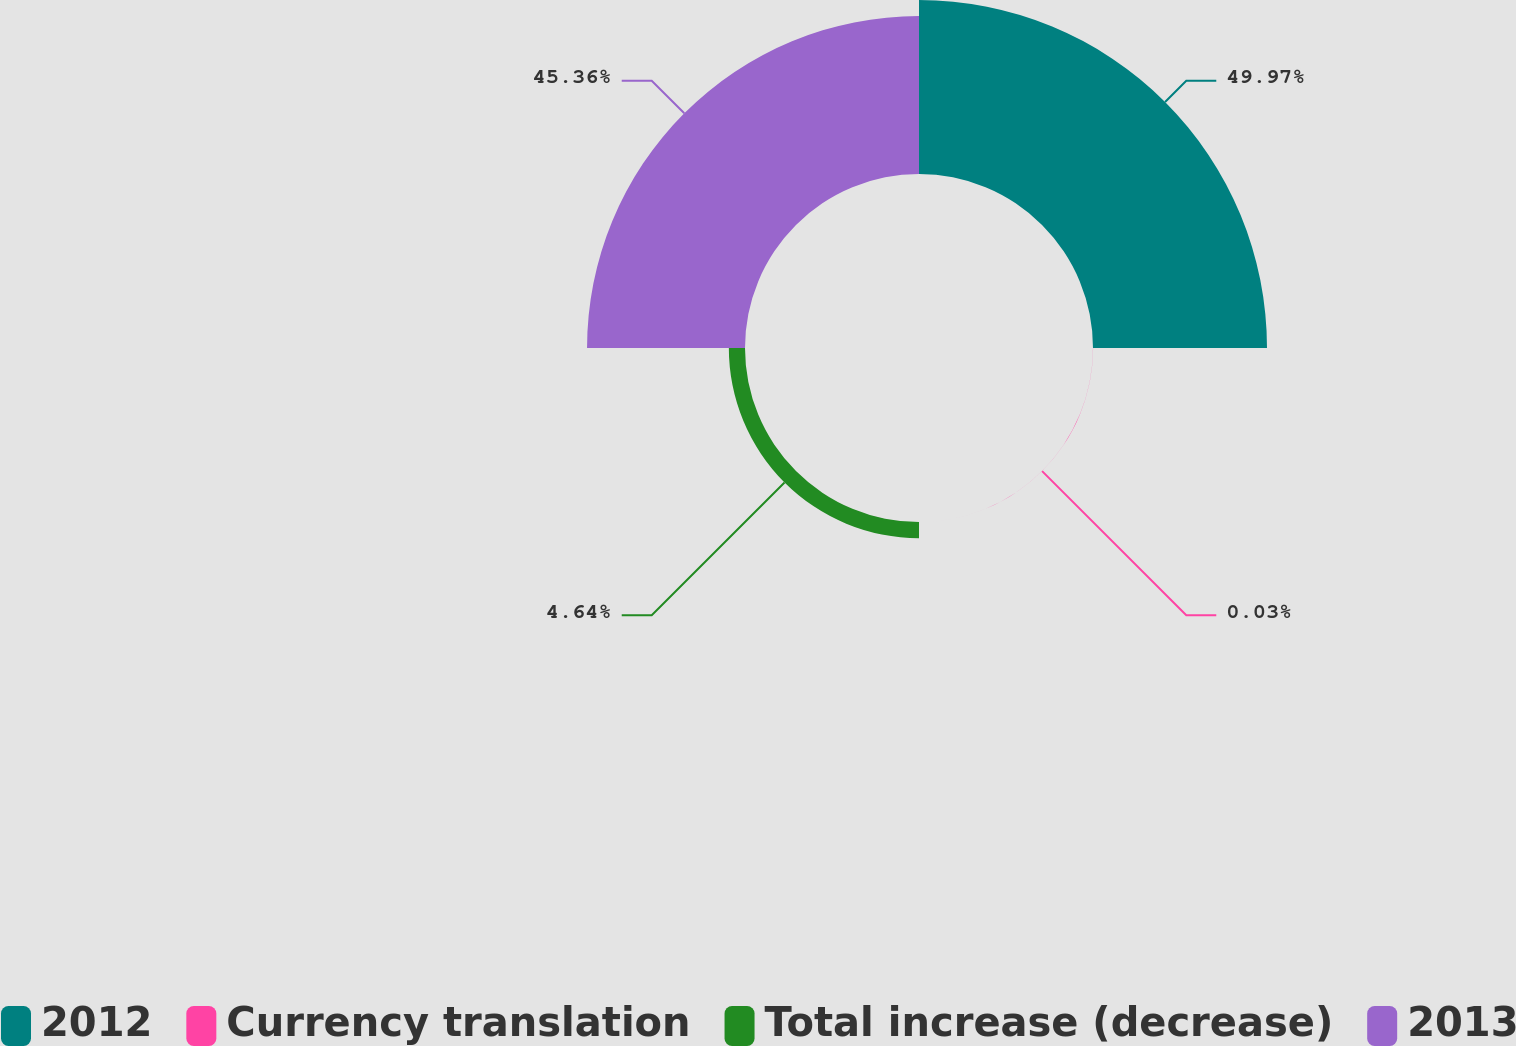Convert chart to OTSL. <chart><loc_0><loc_0><loc_500><loc_500><pie_chart><fcel>2012<fcel>Currency translation<fcel>Total increase (decrease)<fcel>2013<nl><fcel>49.97%<fcel>0.03%<fcel>4.64%<fcel>45.36%<nl></chart> 